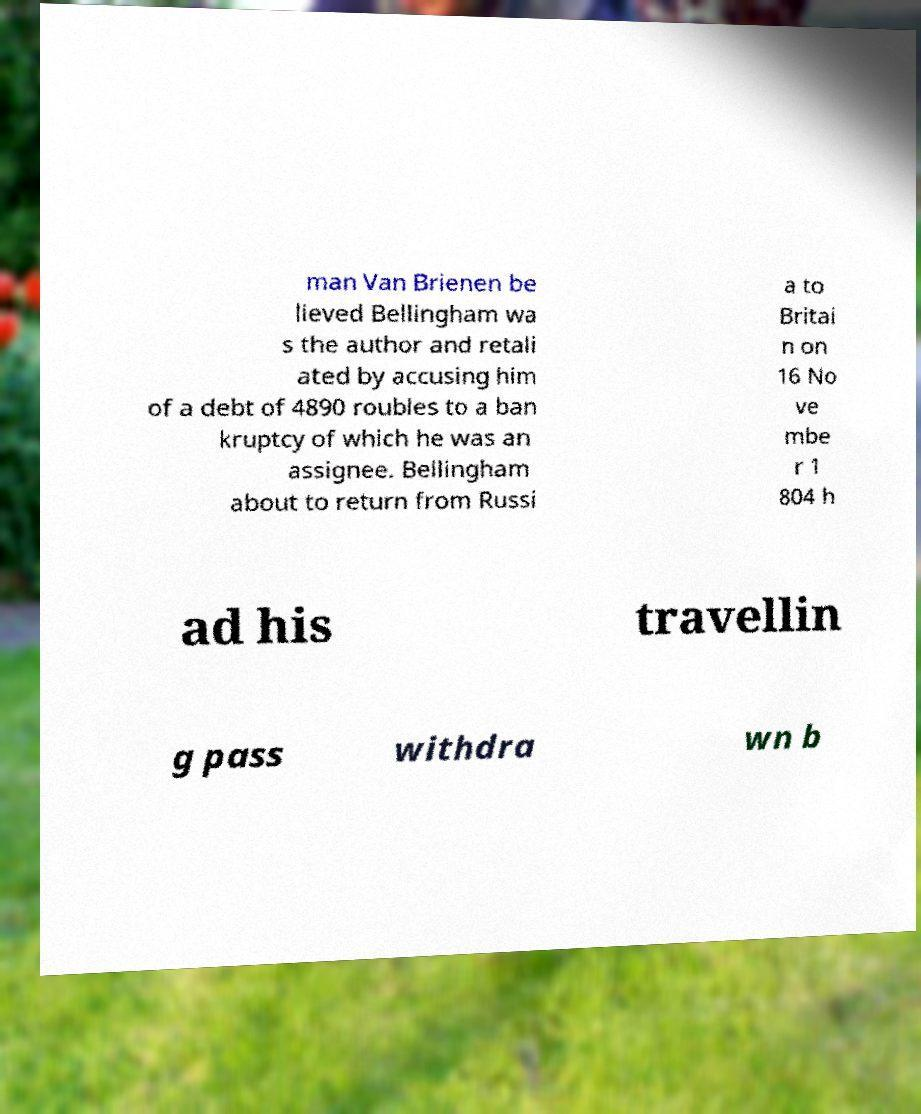Could you extract and type out the text from this image? man Van Brienen be lieved Bellingham wa s the author and retali ated by accusing him of a debt of 4890 roubles to a ban kruptcy of which he was an assignee. Bellingham about to return from Russi a to Britai n on 16 No ve mbe r 1 804 h ad his travellin g pass withdra wn b 